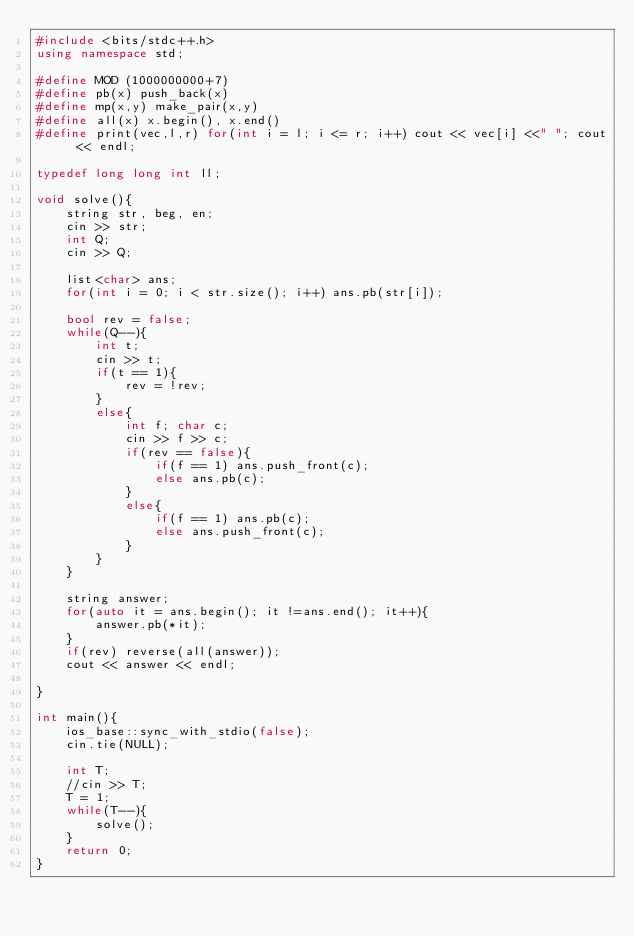Convert code to text. <code><loc_0><loc_0><loc_500><loc_500><_C++_>#include <bits/stdc++.h>
using namespace std;

#define MOD (1000000000+7)
#define pb(x) push_back(x)
#define mp(x,y) make_pair(x,y)
#define all(x) x.begin(), x.end()
#define print(vec,l,r) for(int i = l; i <= r; i++) cout << vec[i] <<" "; cout << endl;

typedef long long int ll;

void solve(){
	string str, beg, en;
	cin >> str;
	int Q;
	cin >> Q;
	
	list<char> ans;
	for(int i = 0; i < str.size(); i++) ans.pb(str[i]);
	
	bool rev = false;
	while(Q--){
		int t;
		cin >> t;
		if(t == 1){
			rev = !rev;
		}
		else{
			int f; char c;
			cin >> f >> c;
			if(rev == false){
				if(f == 1) ans.push_front(c);
				else ans.pb(c);
			}
			else{
				if(f == 1) ans.pb(c);
				else ans.push_front(c);
			}
		}
	}
	
	string answer;
	for(auto it = ans.begin(); it !=ans.end(); it++){
		answer.pb(*it);
	}
	if(rev) reverse(all(answer));
	cout << answer << endl;
	
}

int main(){
 	ios_base::sync_with_stdio(false);
    cin.tie(NULL);

	int T;
	//cin >> T;
	T = 1;
	while(T--){
		solve();
	}
	return 0;
}


</code> 